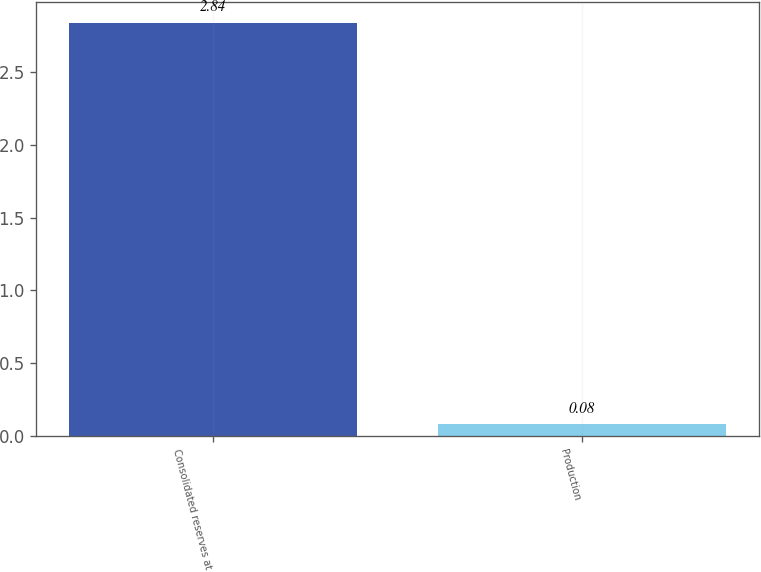Convert chart. <chart><loc_0><loc_0><loc_500><loc_500><bar_chart><fcel>Consolidated reserves at<fcel>Production<nl><fcel>2.84<fcel>0.08<nl></chart> 